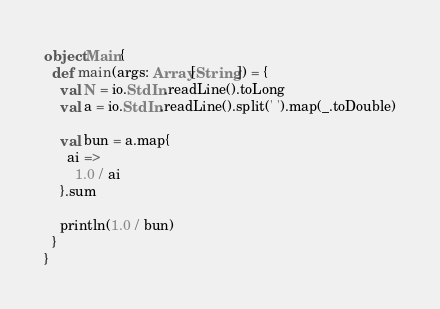Convert code to text. <code><loc_0><loc_0><loc_500><loc_500><_Scala_>object Main{
  def main(args: Array[String]) = {
    val N = io.StdIn.readLine().toLong
    val a = io.StdIn.readLine().split(' ').map(_.toDouble)

    val bun = a.map{
      ai =>
        1.0 / ai
    }.sum

    println(1.0 / bun)
  }
}</code> 